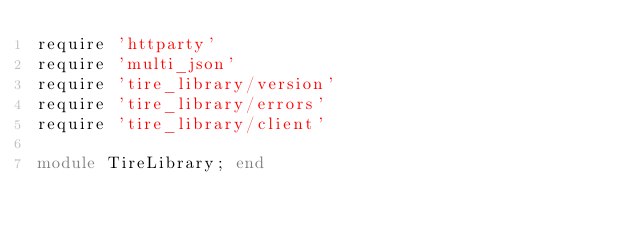<code> <loc_0><loc_0><loc_500><loc_500><_Ruby_>require 'httparty'
require 'multi_json'
require 'tire_library/version'
require 'tire_library/errors'
require 'tire_library/client'

module TireLibrary; end
</code> 